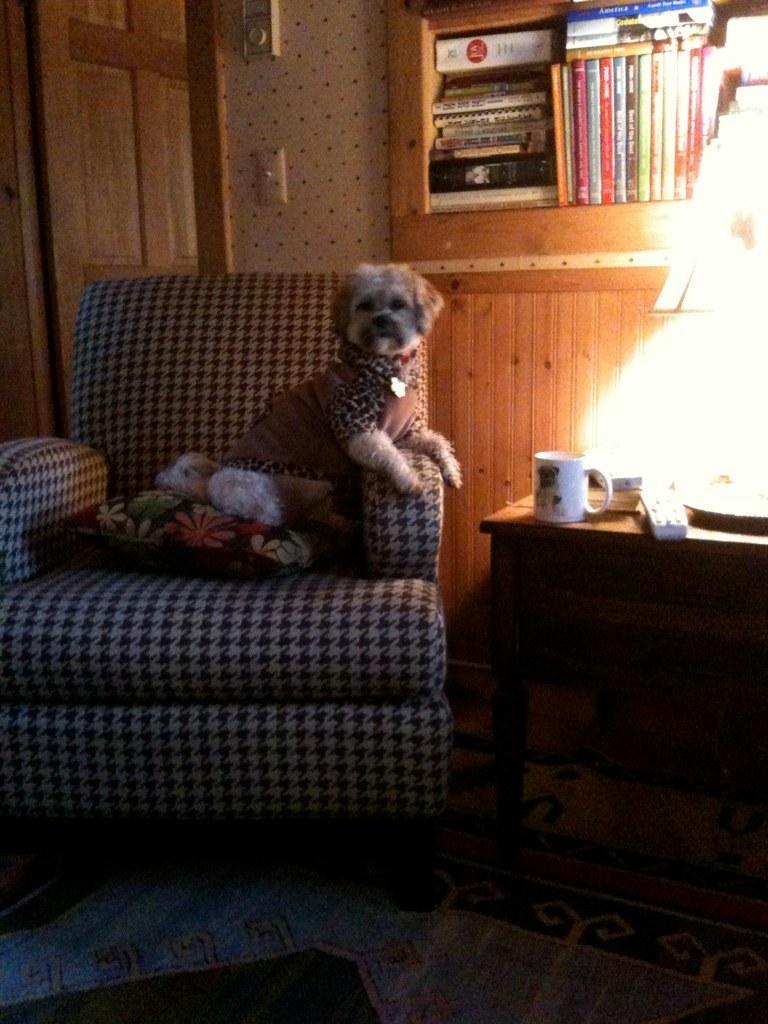Describe this image in one or two sentences. It is a room inside the house , there is a sofa and a pillow above the sofa and there is a dog sitting in the sofa, to the right side of the sofa there is a table on which there is a lamp, mug and a remote. Behind the sofa there is a bookshelf with books inside it, in the background there is a wall and beside the wall there is a door. 